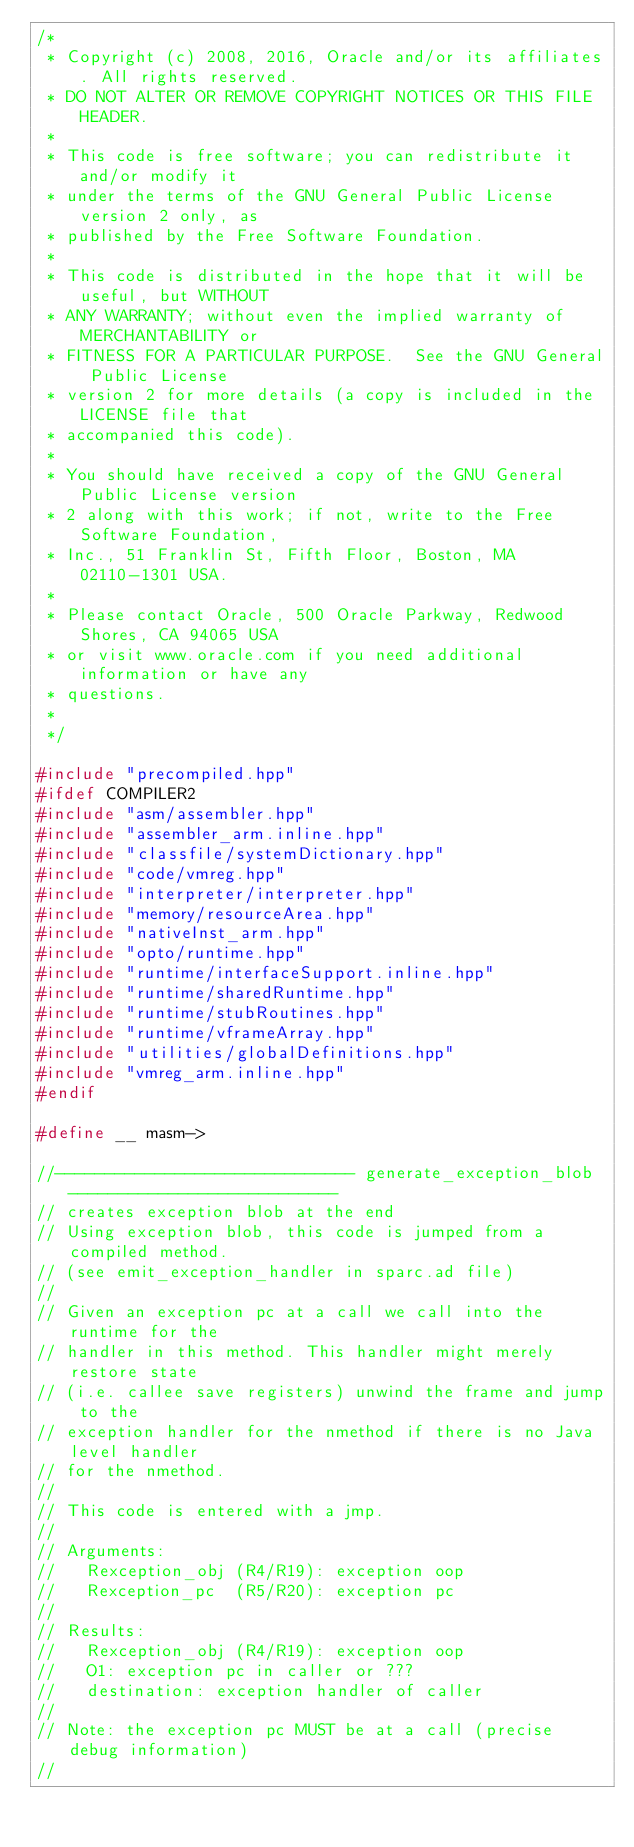Convert code to text. <code><loc_0><loc_0><loc_500><loc_500><_C++_>/*
 * Copyright (c) 2008, 2016, Oracle and/or its affiliates. All rights reserved.
 * DO NOT ALTER OR REMOVE COPYRIGHT NOTICES OR THIS FILE HEADER.
 *
 * This code is free software; you can redistribute it and/or modify it
 * under the terms of the GNU General Public License version 2 only, as
 * published by the Free Software Foundation.
 *
 * This code is distributed in the hope that it will be useful, but WITHOUT
 * ANY WARRANTY; without even the implied warranty of MERCHANTABILITY or
 * FITNESS FOR A PARTICULAR PURPOSE.  See the GNU General Public License
 * version 2 for more details (a copy is included in the LICENSE file that
 * accompanied this code).
 *
 * You should have received a copy of the GNU General Public License version
 * 2 along with this work; if not, write to the Free Software Foundation,
 * Inc., 51 Franklin St, Fifth Floor, Boston, MA 02110-1301 USA.
 *
 * Please contact Oracle, 500 Oracle Parkway, Redwood Shores, CA 94065 USA
 * or visit www.oracle.com if you need additional information or have any
 * questions.
 *
 */

#include "precompiled.hpp"
#ifdef COMPILER2
#include "asm/assembler.hpp"
#include "assembler_arm.inline.hpp"
#include "classfile/systemDictionary.hpp"
#include "code/vmreg.hpp"
#include "interpreter/interpreter.hpp"
#include "memory/resourceArea.hpp"
#include "nativeInst_arm.hpp"
#include "opto/runtime.hpp"
#include "runtime/interfaceSupport.inline.hpp"
#include "runtime/sharedRuntime.hpp"
#include "runtime/stubRoutines.hpp"
#include "runtime/vframeArray.hpp"
#include "utilities/globalDefinitions.hpp"
#include "vmreg_arm.inline.hpp"
#endif

#define __ masm->

//------------------------------ generate_exception_blob ---------------------------
// creates exception blob at the end
// Using exception blob, this code is jumped from a compiled method.
// (see emit_exception_handler in sparc.ad file)
//
// Given an exception pc at a call we call into the runtime for the
// handler in this method. This handler might merely restore state
// (i.e. callee save registers) unwind the frame and jump to the
// exception handler for the nmethod if there is no Java level handler
// for the nmethod.
//
// This code is entered with a jmp.
//
// Arguments:
//   Rexception_obj (R4/R19): exception oop
//   Rexception_pc  (R5/R20): exception pc
//
// Results:
//   Rexception_obj (R4/R19): exception oop
//   O1: exception pc in caller or ???
//   destination: exception handler of caller
//
// Note: the exception pc MUST be at a call (precise debug information)
//</code> 